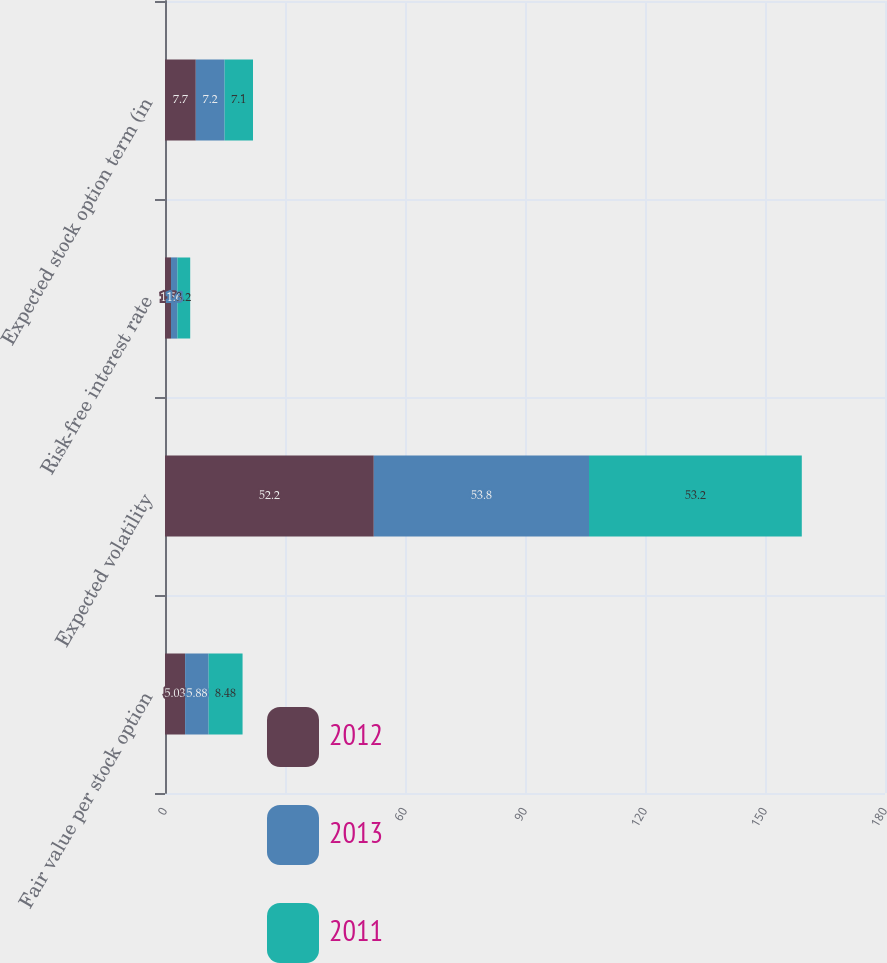Convert chart to OTSL. <chart><loc_0><loc_0><loc_500><loc_500><stacked_bar_chart><ecel><fcel>Fair value per stock option<fcel>Expected volatility<fcel>Risk-free interest rate<fcel>Expected stock option term (in<nl><fcel>2012<fcel>5.03<fcel>52.2<fcel>1.5<fcel>7.7<nl><fcel>2013<fcel>5.88<fcel>53.8<fcel>1.6<fcel>7.2<nl><fcel>2011<fcel>8.48<fcel>53.2<fcel>3.2<fcel>7.1<nl></chart> 